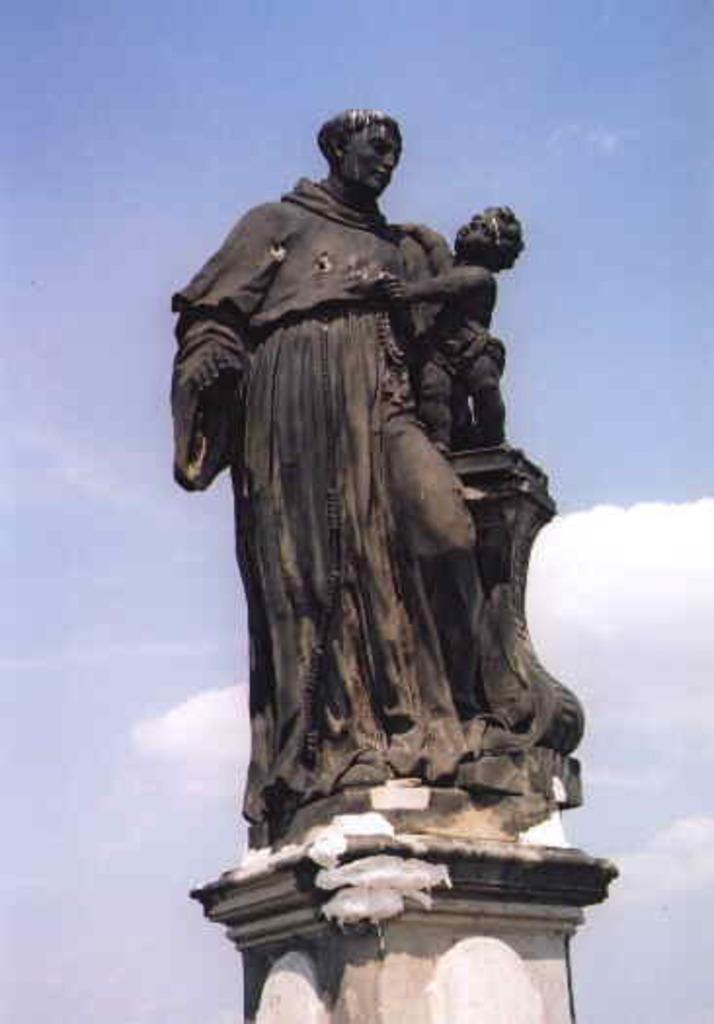What is the main subject in the middle of the image? There is a statue of a person in the image. Where is the statue located in relation to the image? The statue is in the middle of the image. What can be seen in the background of the image? The sky is visible in the background of the image. How many servants are attending to the statue in the image? There are no servants present in the image; it features a statue of a person. What type of business is being conducted near the statue in the image? There is no business activity depicted in the image; it only shows a statue of a person. 